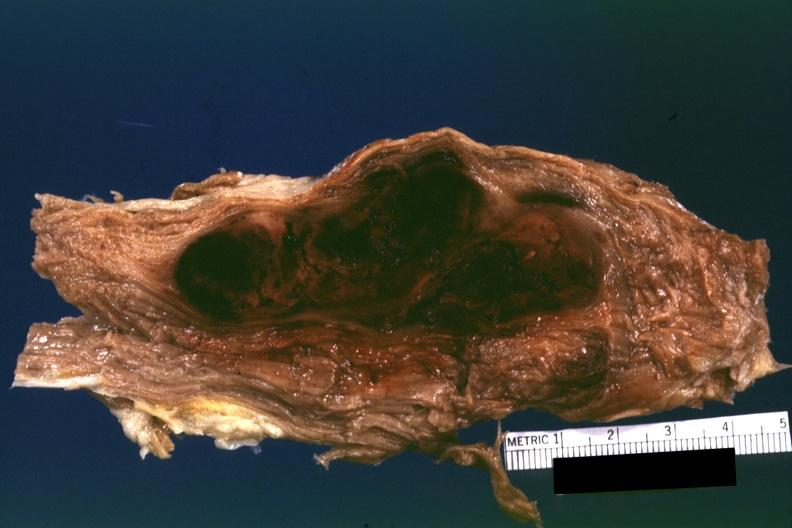does this appear to be in a psoas muscle if so the diagnosis on all other slides of this case in this file needs to be changed?
Answer the question using a single word or phrase. Yes 